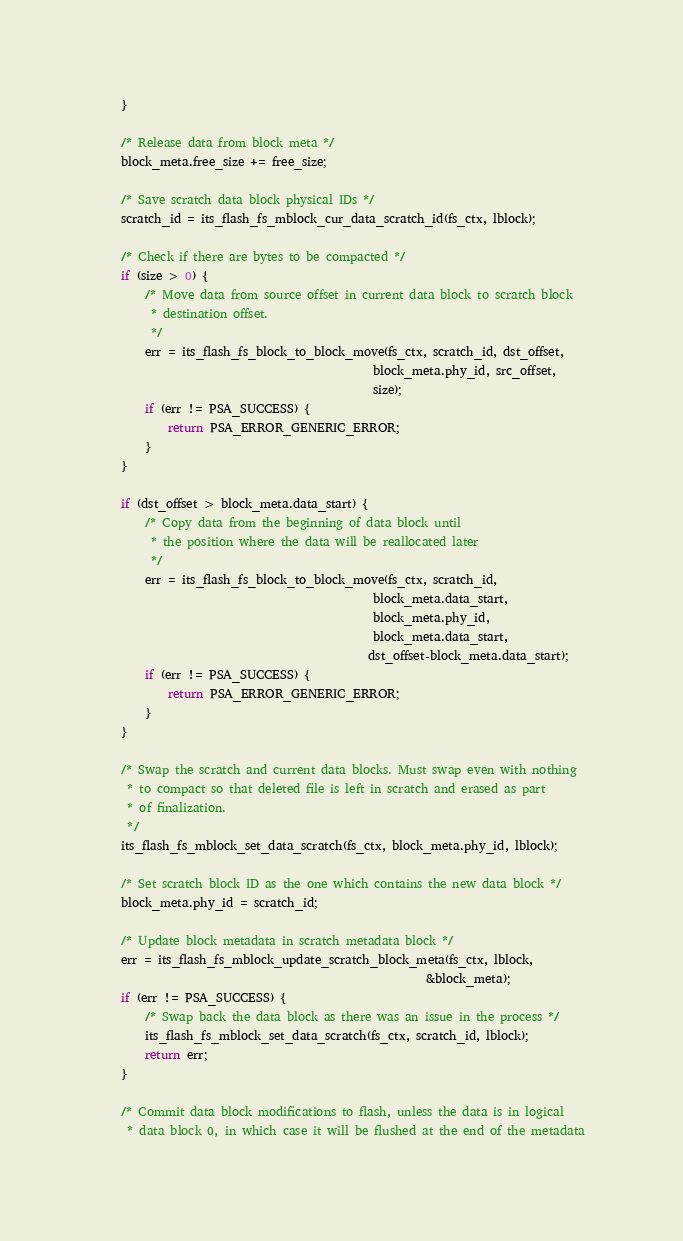<code> <loc_0><loc_0><loc_500><loc_500><_C_>    }

    /* Release data from block meta */
    block_meta.free_size += free_size;

    /* Save scratch data block physical IDs */
    scratch_id = its_flash_fs_mblock_cur_data_scratch_id(fs_ctx, lblock);

    /* Check if there are bytes to be compacted */
    if (size > 0) {
        /* Move data from source offset in current data block to scratch block
         * destination offset.
         */
        err = its_flash_fs_block_to_block_move(fs_ctx, scratch_id, dst_offset,
                                               block_meta.phy_id, src_offset,
                                               size);
        if (err != PSA_SUCCESS) {
            return PSA_ERROR_GENERIC_ERROR;
        }
    }

    if (dst_offset > block_meta.data_start) {
        /* Copy data from the beginning of data block until
         * the position where the data will be reallocated later
         */
        err = its_flash_fs_block_to_block_move(fs_ctx, scratch_id,
                                               block_meta.data_start,
                                               block_meta.phy_id,
                                               block_meta.data_start,
                                              dst_offset-block_meta.data_start);
        if (err != PSA_SUCCESS) {
            return PSA_ERROR_GENERIC_ERROR;
        }
    }

    /* Swap the scratch and current data blocks. Must swap even with nothing
     * to compact so that deleted file is left in scratch and erased as part
     * of finalization.
     */
    its_flash_fs_mblock_set_data_scratch(fs_ctx, block_meta.phy_id, lblock);

    /* Set scratch block ID as the one which contains the new data block */
    block_meta.phy_id = scratch_id;

    /* Update block metadata in scratch metadata block */
    err = its_flash_fs_mblock_update_scratch_block_meta(fs_ctx, lblock,
                                                        &block_meta);
    if (err != PSA_SUCCESS) {
        /* Swap back the data block as there was an issue in the process */
        its_flash_fs_mblock_set_data_scratch(fs_ctx, scratch_id, lblock);
        return err;
    }

    /* Commit data block modifications to flash, unless the data is in logical
     * data block 0, in which case it will be flushed at the end of the metadata</code> 